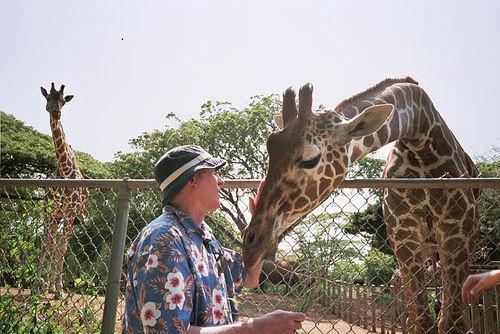How many giraffes are interacting with the man? Please explain your reasoning. one. The man is only touching one giraffe. 